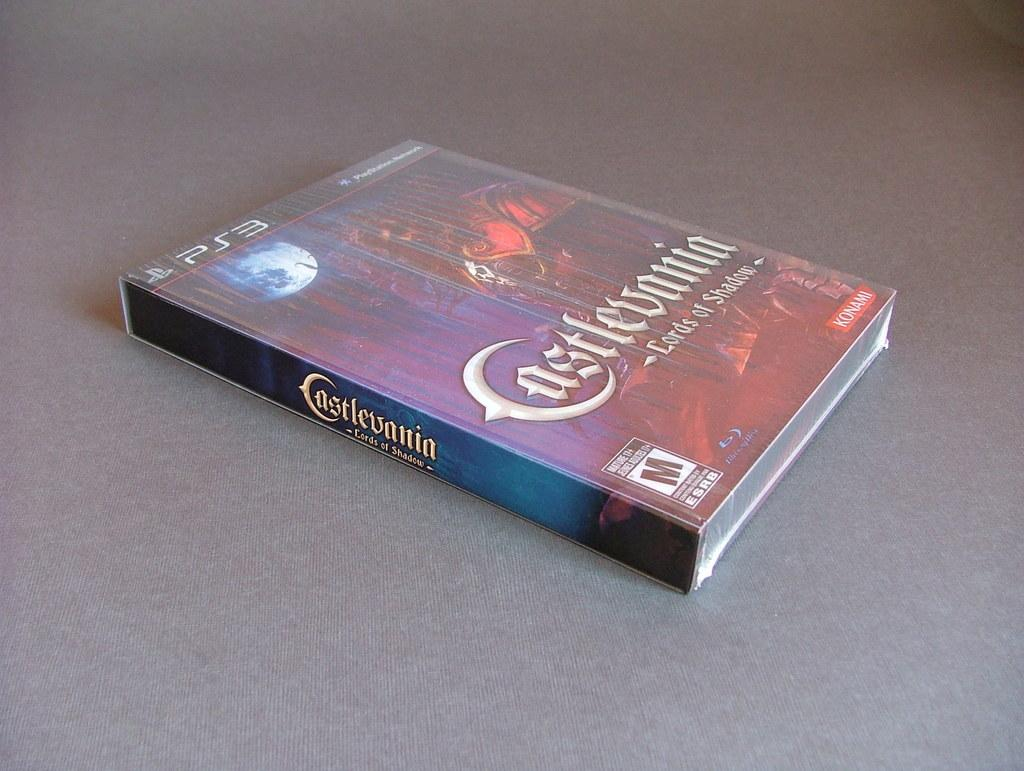What type of item is depicted in the image? There is a compact disc box in the image. What is written on the box? The box has "Castlevania Lords of Shadow" written on it. What can be seen at the bottom of the image? The bottom of the image contains a floor. What type of brush is used to clean the jeans in the image? There are no jeans or brushes present in the image; it only features a compact disc box with "Castlevania Lords of Shadow" written on it and a floor at the bottom. 